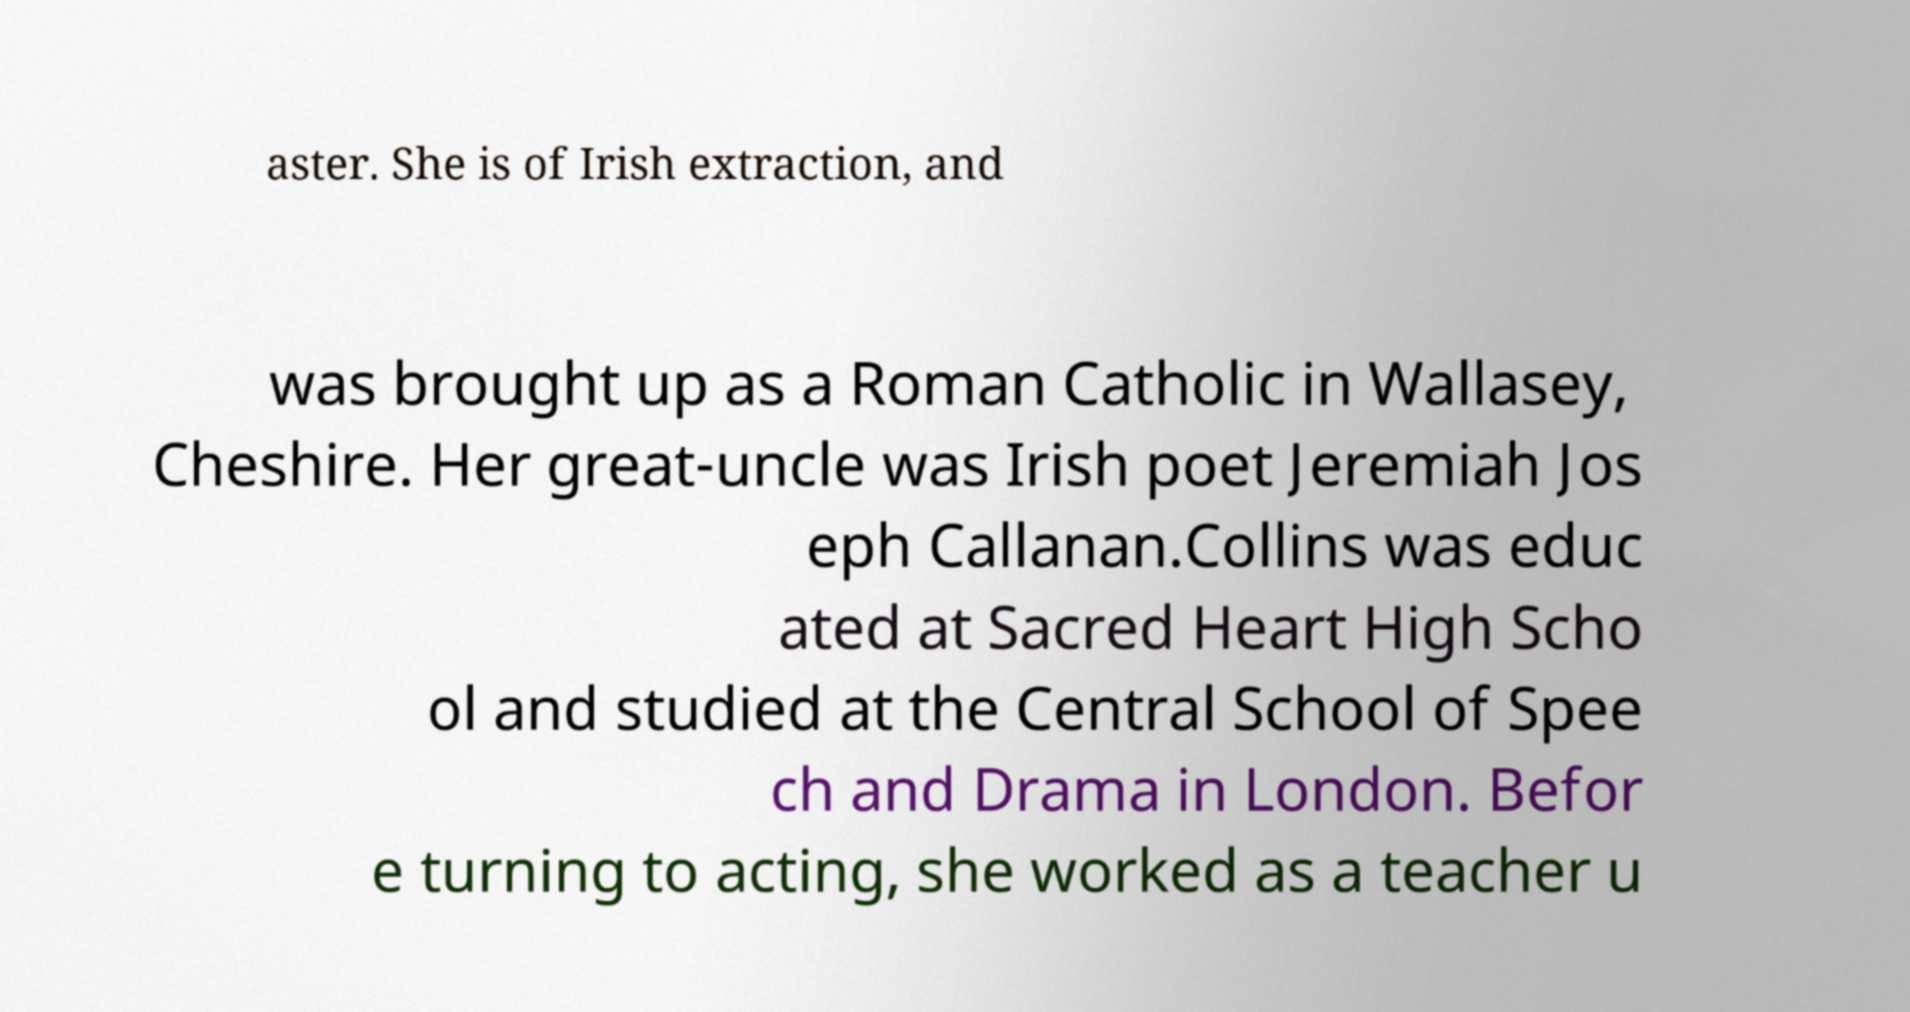Can you read and provide the text displayed in the image?This photo seems to have some interesting text. Can you extract and type it out for me? aster. She is of Irish extraction, and was brought up as a Roman Catholic in Wallasey, Cheshire. Her great-uncle was Irish poet Jeremiah Jos eph Callanan.Collins was educ ated at Sacred Heart High Scho ol and studied at the Central School of Spee ch and Drama in London. Befor e turning to acting, she worked as a teacher u 